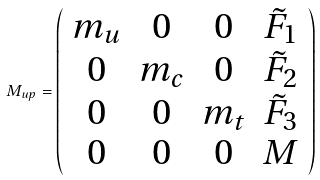<formula> <loc_0><loc_0><loc_500><loc_500>M _ { u p } = \left ( \begin{array} { c c c c } m _ { u } & 0 & 0 & \tilde { F } _ { 1 } \\ 0 & m _ { c } & 0 & \tilde { F } _ { 2 } \\ 0 & 0 & m _ { t } & \tilde { F } _ { 3 } \\ 0 & 0 & 0 & M \end{array} \right )</formula> 